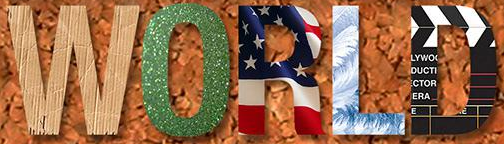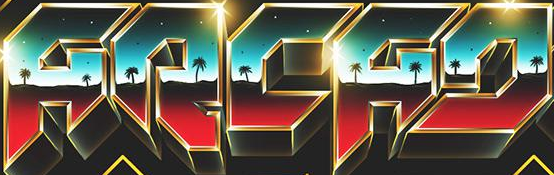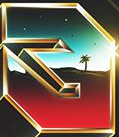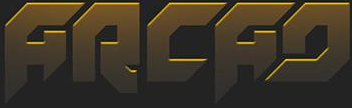What words can you see in these images in sequence, separated by a semicolon? WORLD; ARCAD; #; ARCAD 